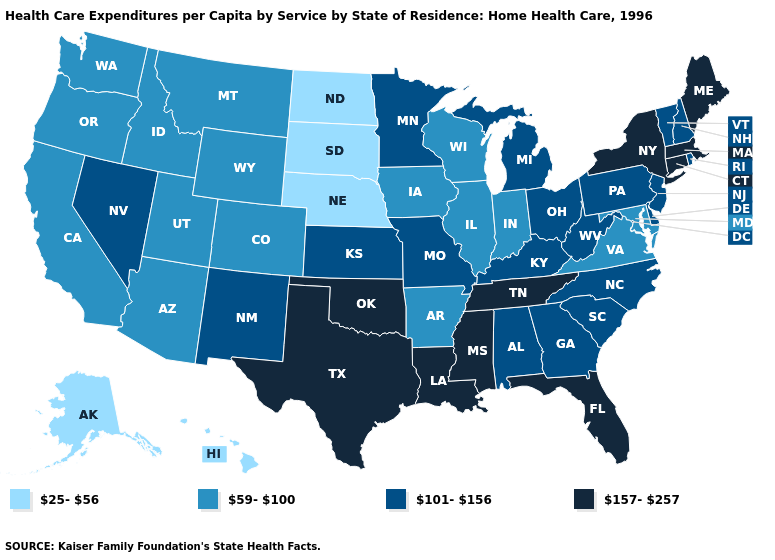Does Connecticut have the highest value in the USA?
Quick response, please. Yes. What is the value of Connecticut?
Quick response, please. 157-257. What is the value of Michigan?
Short answer required. 101-156. What is the highest value in states that border North Dakota?
Be succinct. 101-156. What is the value of Florida?
Quick response, please. 157-257. What is the highest value in the USA?
Write a very short answer. 157-257. Does the first symbol in the legend represent the smallest category?
Give a very brief answer. Yes. Name the states that have a value in the range 101-156?
Write a very short answer. Alabama, Delaware, Georgia, Kansas, Kentucky, Michigan, Minnesota, Missouri, Nevada, New Hampshire, New Jersey, New Mexico, North Carolina, Ohio, Pennsylvania, Rhode Island, South Carolina, Vermont, West Virginia. Does the first symbol in the legend represent the smallest category?
Concise answer only. Yes. Does Pennsylvania have the lowest value in the Northeast?
Give a very brief answer. Yes. Among the states that border Montana , does Wyoming have the lowest value?
Keep it brief. No. Among the states that border Georgia , does Florida have the lowest value?
Concise answer only. No. What is the lowest value in the USA?
Write a very short answer. 25-56. Name the states that have a value in the range 157-257?
Quick response, please. Connecticut, Florida, Louisiana, Maine, Massachusetts, Mississippi, New York, Oklahoma, Tennessee, Texas. What is the value of Missouri?
Give a very brief answer. 101-156. 